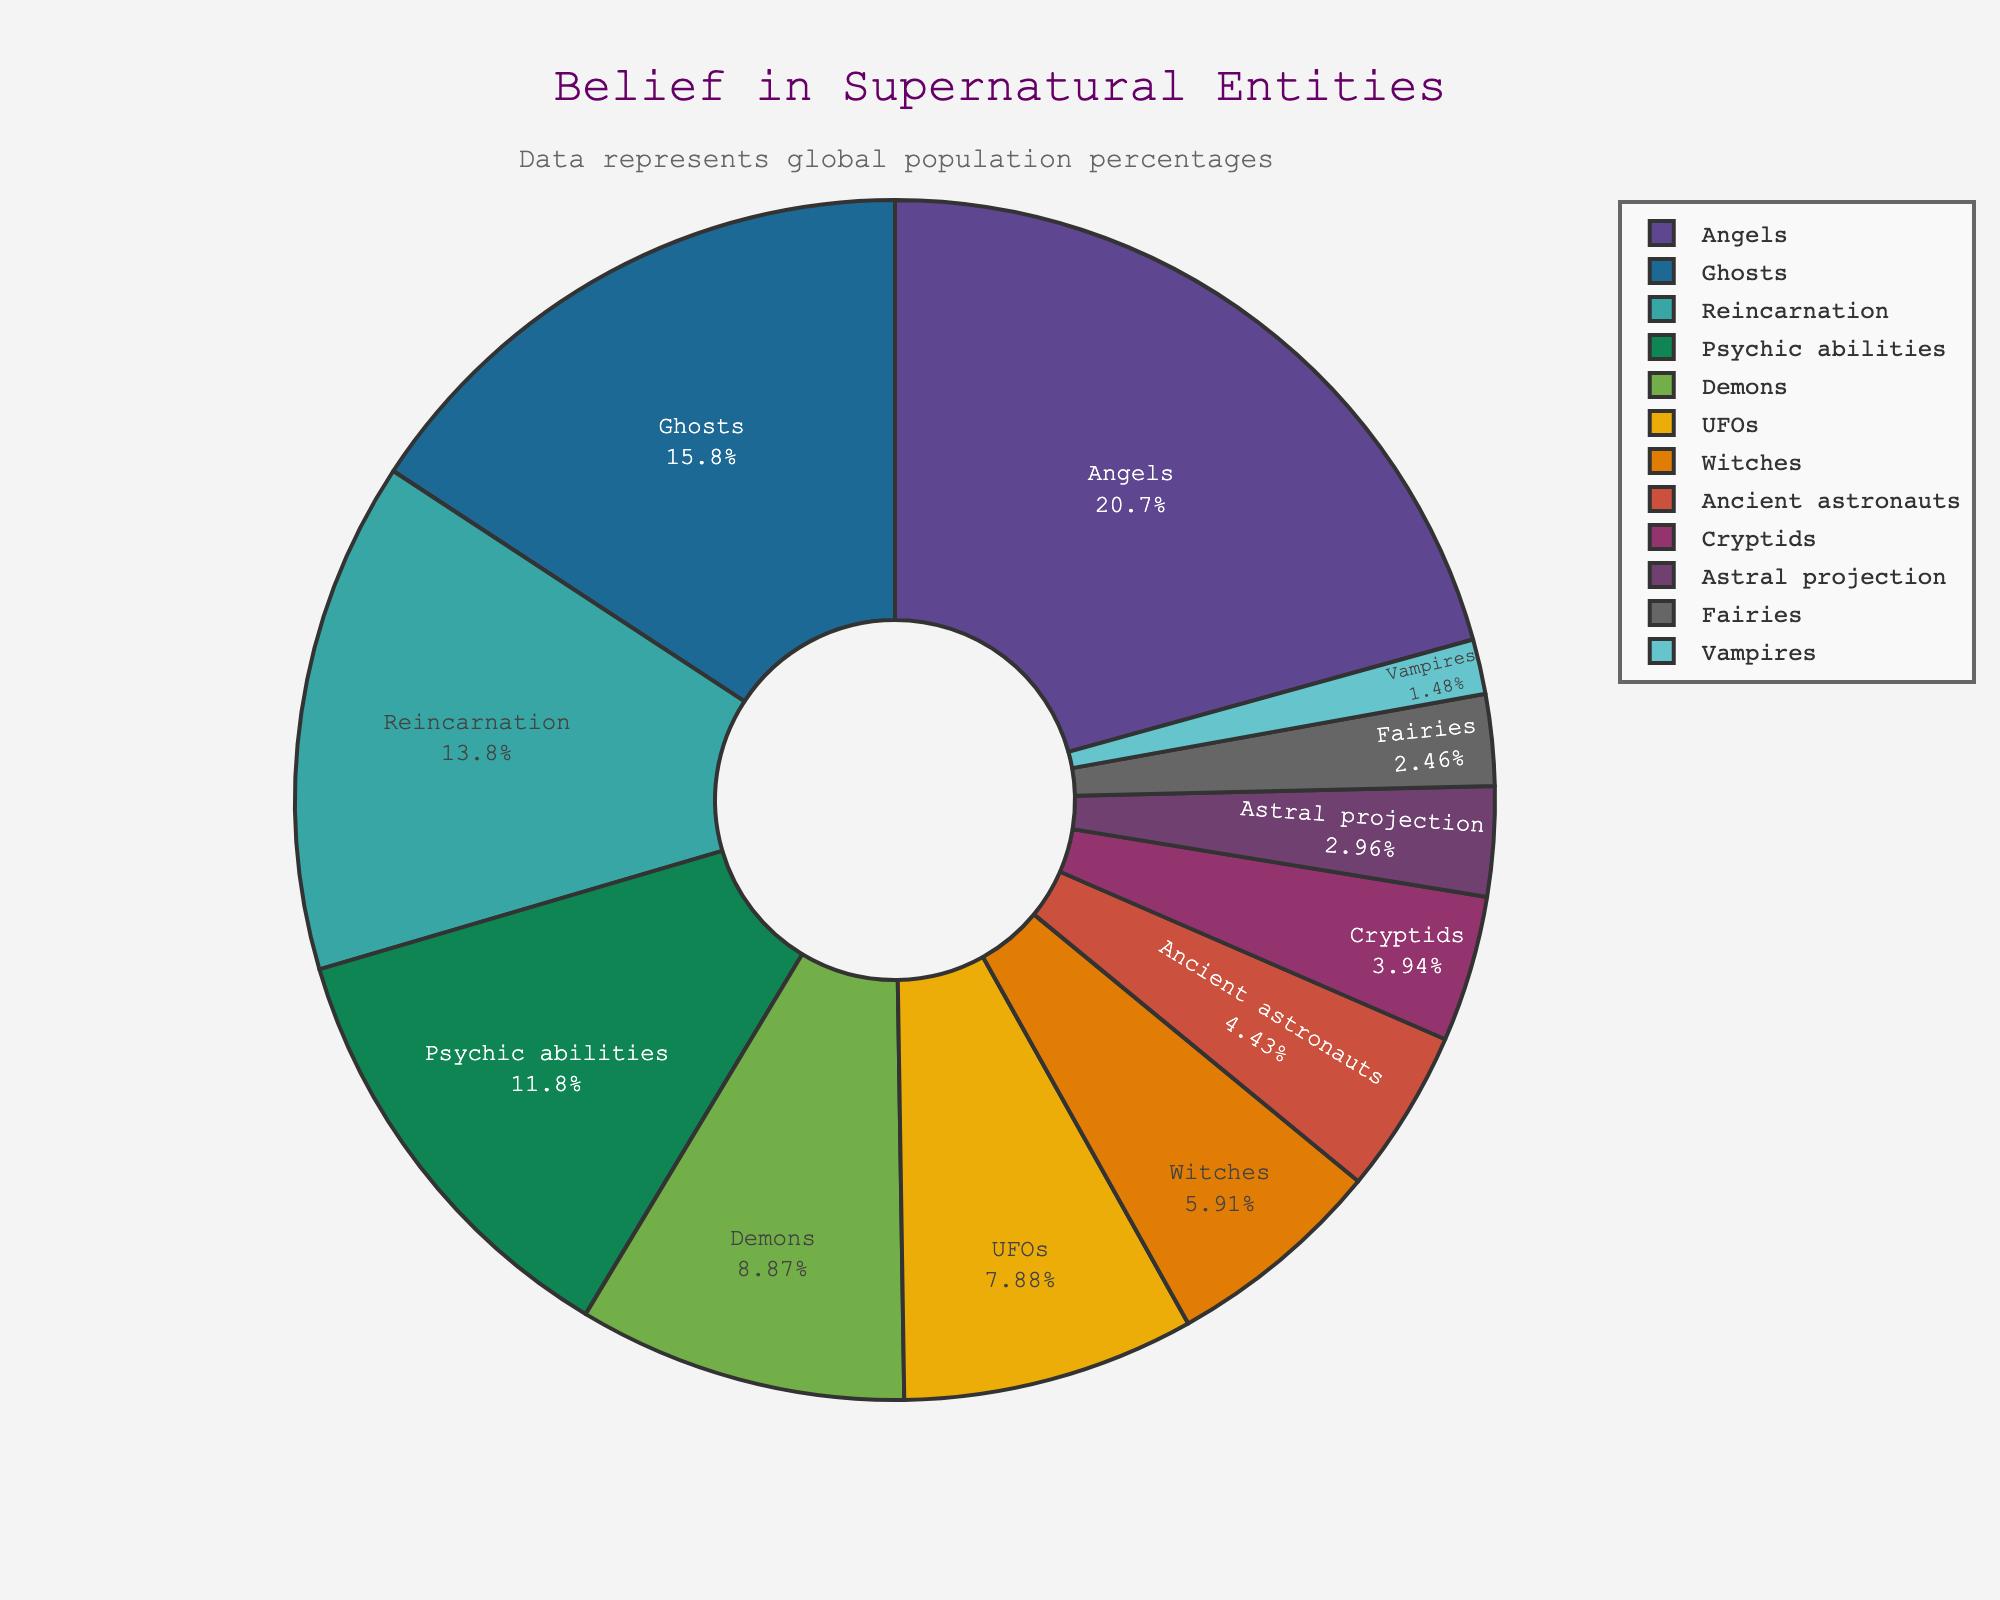Which supernatural entity has the highest percentage of global belief? By examining the pie chart, we observe that the segment labeled "Angels" is the largest, indicating the highest percentage of global belief.
Answer: Angels Which three supernatural entities have the lowest percentages of global belief, and what are their percentages? The pie chart shows that "Vampires," "Astral projection," and "Fairies" have the smallest segments, indicating the lowest percentages of global belief at 3%, 6%, and 5% respectively.
Answer: Vampires (3%), Astral projection (6%), Fairies (5%) What is the total percentage of people who believe in either Demons or Angels? To find the combined percentage of people who believe in either Demons or Angels, add their individual percentages from the pie chart: 18% (Demons) + 42% (Angels) = 60%.
Answer: 60% Compare the belief in Ghosts and UFOs. Which is greater, and by how much? The pie chart shows that 32% of people believe in Ghosts, while 16% believe in UFOs. The difference is 32% - 16% = 16%. Therefore, belief in Ghosts is greater by 16%.
Answer: Ghosts by 16% Are more people believed in Cryptids or Ancient astronauts, and what is the percentage difference? From the chart, 8% believe in Cryptids, and 9% believe in Ancient astronauts. The difference is 1%, with more people believing in Ancient astronauts.
Answer: Ancient astronauts by 1% What is the total percentage of people believing in supernatural entities associated with an afterlife (e.g., Angels, Demons, Reincarnation)? To calculate this, add the percentages of people who believe in Angels (42%), Demons (18%), and Reincarnation (28%): 42% + 18% + 28% = 88%.
Answer: 88% Which has a greater percentage of belief: Psychic abilities or Witches? According to the pie chart, 24% of people believe in Psychic abilities, while 12% believe in Witches. Thus, belief in Psychic abilities is greater.
Answer: Psychic abilities What proportion of the total belief does the top three supernatural entities (by percentage) represent? From the chart, the top three entities are Angels (42%), Ghosts (32%), and Reincarnation (28%). Adding these percentages gives 42% + 32% + 28% = 102% of the total belief.
Answer: 102% Describe the color associated with the largest segment in the pie chart. The pie chart uses a custom color palette, and the largest segment, "Angels," is colored prominently, usually standing out visually to represent its large percentage. It's typically a distinct and eye-catching color.
Answer: [Specific color description] 